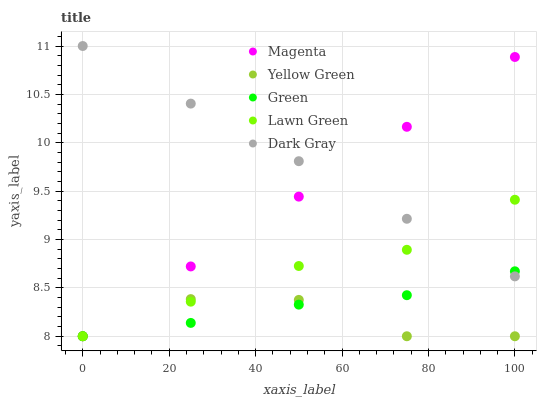Does Yellow Green have the minimum area under the curve?
Answer yes or no. Yes. Does Dark Gray have the maximum area under the curve?
Answer yes or no. Yes. Does Lawn Green have the minimum area under the curve?
Answer yes or no. No. Does Lawn Green have the maximum area under the curve?
Answer yes or no. No. Is Dark Gray the smoothest?
Answer yes or no. Yes. Is Yellow Green the roughest?
Answer yes or no. Yes. Is Lawn Green the smoothest?
Answer yes or no. No. Is Lawn Green the roughest?
Answer yes or no. No. Does Lawn Green have the lowest value?
Answer yes or no. Yes. Does Dark Gray have the highest value?
Answer yes or no. Yes. Does Lawn Green have the highest value?
Answer yes or no. No. Is Yellow Green less than Dark Gray?
Answer yes or no. Yes. Is Dark Gray greater than Yellow Green?
Answer yes or no. Yes. Does Green intersect Magenta?
Answer yes or no. Yes. Is Green less than Magenta?
Answer yes or no. No. Is Green greater than Magenta?
Answer yes or no. No. Does Yellow Green intersect Dark Gray?
Answer yes or no. No. 